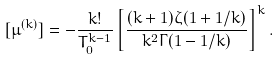Convert formula to latex. <formula><loc_0><loc_0><loc_500><loc_500>[ \mu ^ { ( k ) } ] = - \frac { k ! } { T _ { 0 } ^ { k - 1 } } \left [ \frac { ( k + 1 ) \zeta ( 1 + 1 / k ) } { k ^ { 2 } \Gamma ( 1 - 1 / k ) } \right ] ^ { k } .</formula> 